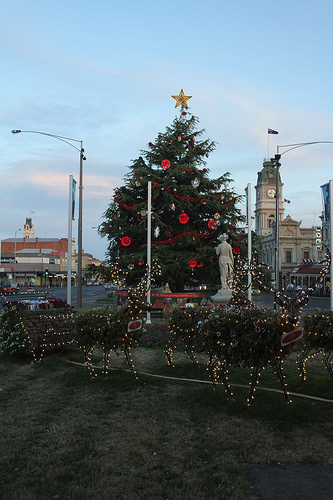<image>
Is the star next to the clock? No. The star is not positioned next to the clock. They are located in different areas of the scene. 